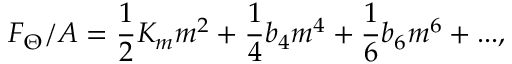<formula> <loc_0><loc_0><loc_500><loc_500>F _ { \Theta } / A = \frac { 1 } { 2 } K _ { m } m ^ { 2 } + \frac { 1 } { 4 } b _ { 4 } m ^ { 4 } + \frac { 1 } { 6 } b _ { 6 } m ^ { 6 } + \dots ,</formula> 